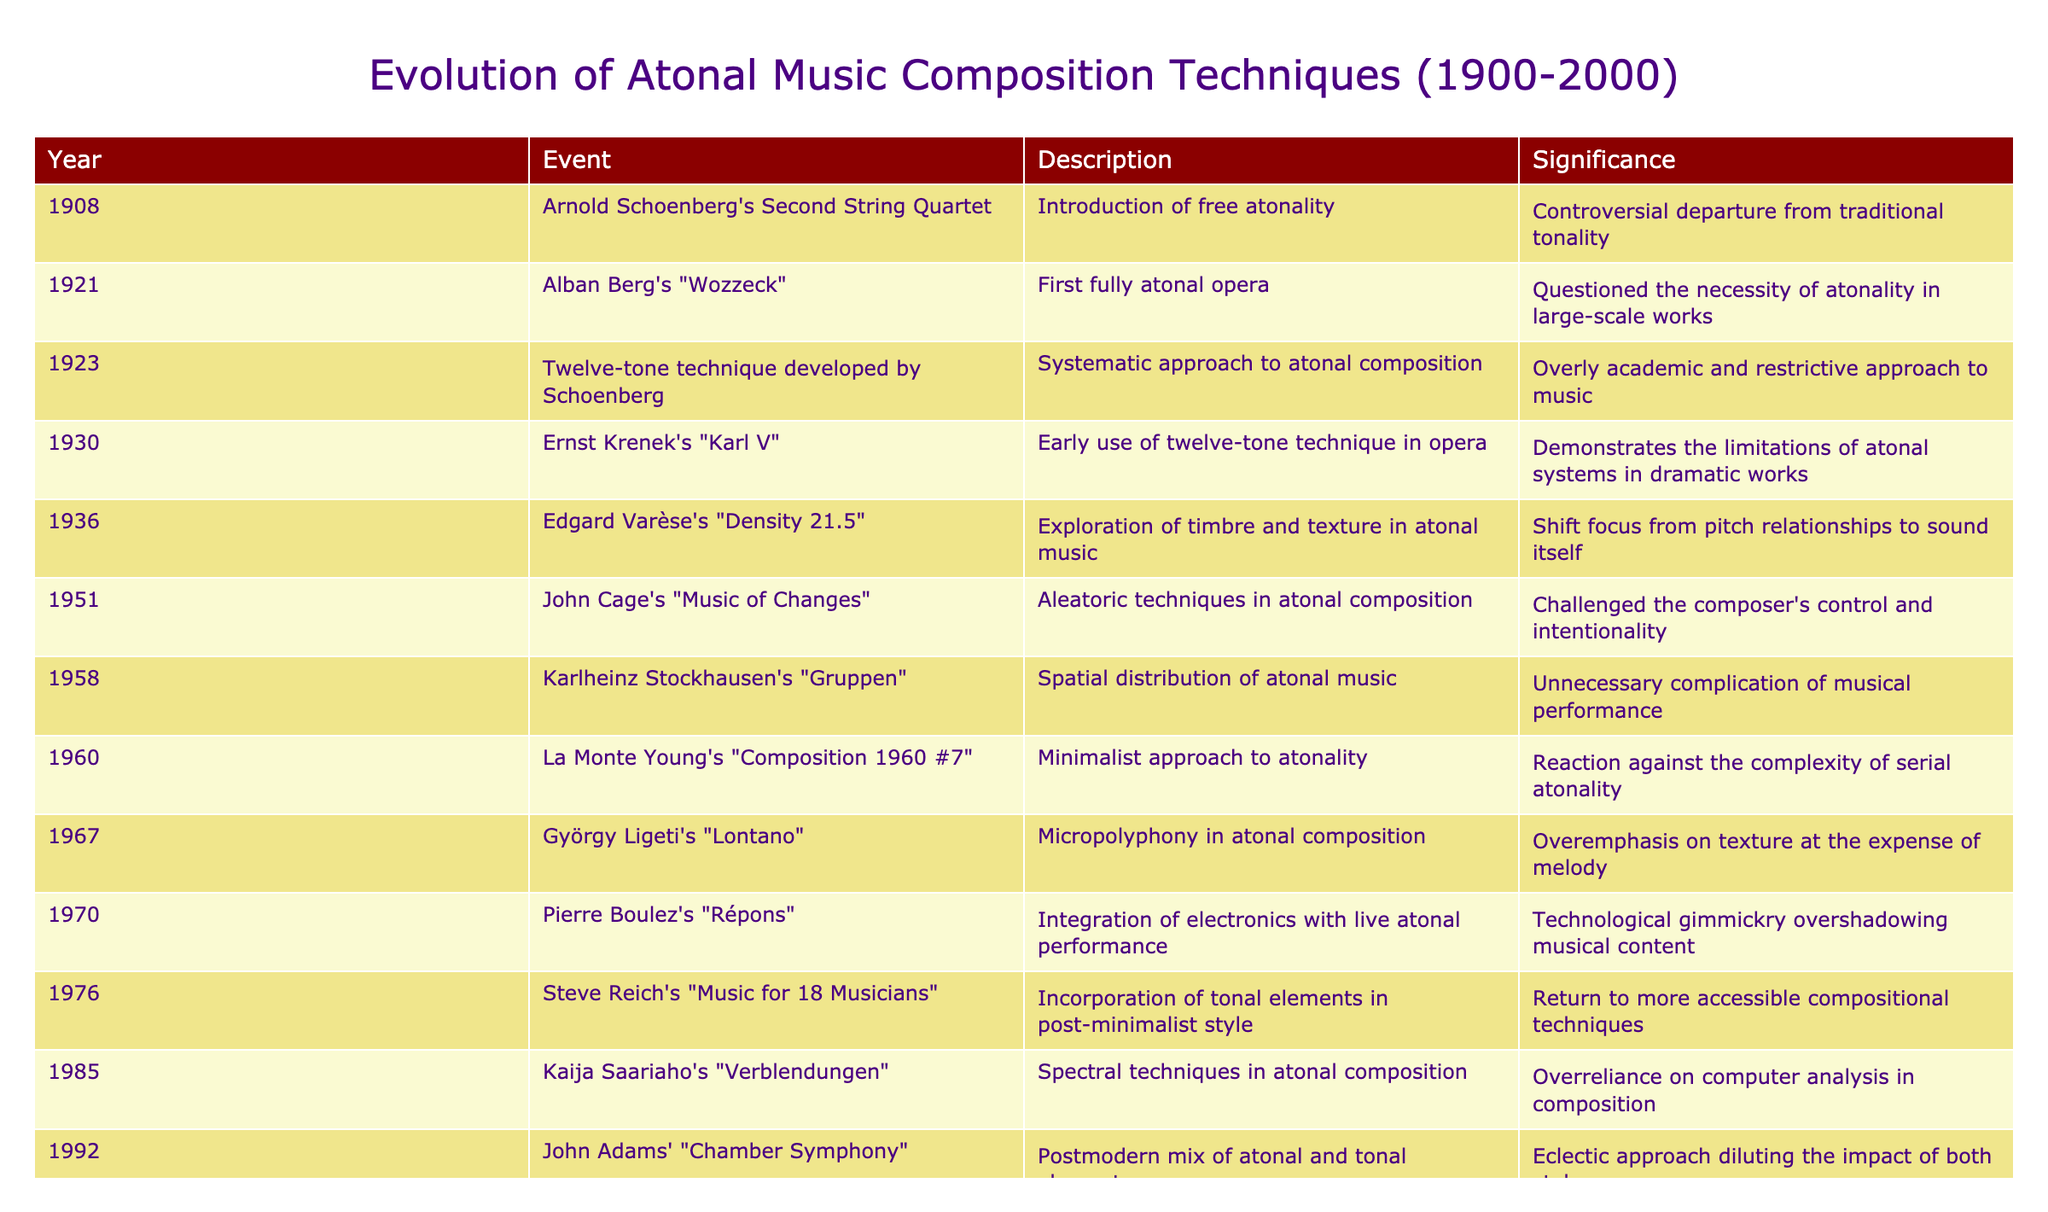What year did Alban Berg's "Wozzeck" premiere? The table specifies that Alban Berg's "Wozzeck" was premiered in the year 1921.
Answer: 1921 Which event marked the first fully atonal opera? According to the table, Alban Berg's "Wozzeck" is noted as the first fully atonal opera, which aligns with the event listed in 1921.
Answer: Alban Berg's "Wozzeck" Was the twelve-tone technique first developed by Arnold Schoenberg? The table confirms that the twelve-tone technique was developed by Schoenberg in 1923, making the statement true.
Answer: Yes What is the significance of Edgard Varèse's "Density 21.5" in terms of composition focus? The table states that this piece shifted the focus from pitch relationships to sound itself, indicating a change in compositional emphasis.
Answer: Shift focus from pitch to sound Between which years did Pierre Boulez's "Répons" and John Adams' "Chamber Symphony" occur? By examining the years listed, "Répons" occurred in 1970 and "Chamber Symphony" in 1992, so the range is 1970 to 1992.
Answer: 1970 to 1992 What was the general trend in atonal compositional techniques from the 1950s to the 1990s, according to the table? A pattern emerges where composers began incorporating tonal elements and various modern techniques, moving away from strict atonality. Notably, Steve Reich's work in 1976 introduced tonal elements, which contrasts with earlier purely atonal techniques.
Answer: Shift towards tonal elements and eclectic techniques How many events listed took place in the 1980s? Reviewing the table, there is one event in the 1980s, specifically Kaija Saariaho's "Verblendungen" from 1985.
Answer: 1 Was "Music of Changes" by John Cage an example of aleatoric music? The table explicitly categorizes "Music of Changes" as utilizing aleatoric techniques, confirming the statement.
Answer: Yes Which composition emphasizes micropolyphony, and in what year was it created? The table notes that György Ligeti's "Lontano," created in 1967, is an example that emphasizes micropolyphony.
Answer: György Ligeti's "Lontano" in 1967 What significant technological integration is noted in Boulez's "Répons"? The table describes an integration of electronics with live performance, highlighting a technological advancement in atonal music during that piece's era.
Answer: Integration of electronics with live performance 